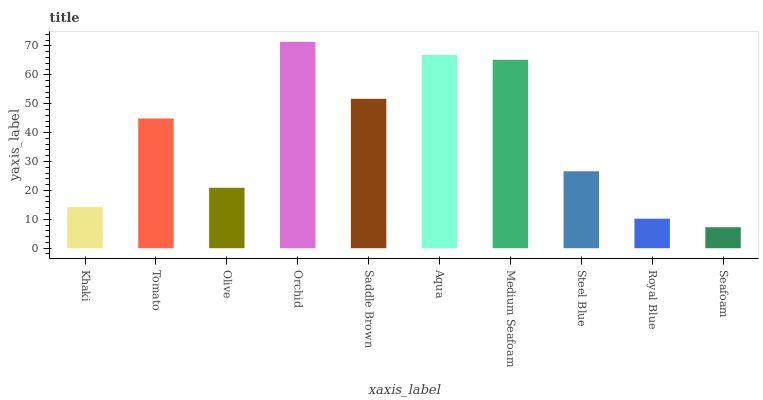Is Seafoam the minimum?
Answer yes or no. Yes. Is Orchid the maximum?
Answer yes or no. Yes. Is Tomato the minimum?
Answer yes or no. No. Is Tomato the maximum?
Answer yes or no. No. Is Tomato greater than Khaki?
Answer yes or no. Yes. Is Khaki less than Tomato?
Answer yes or no. Yes. Is Khaki greater than Tomato?
Answer yes or no. No. Is Tomato less than Khaki?
Answer yes or no. No. Is Tomato the high median?
Answer yes or no. Yes. Is Steel Blue the low median?
Answer yes or no. Yes. Is Aqua the high median?
Answer yes or no. No. Is Tomato the low median?
Answer yes or no. No. 